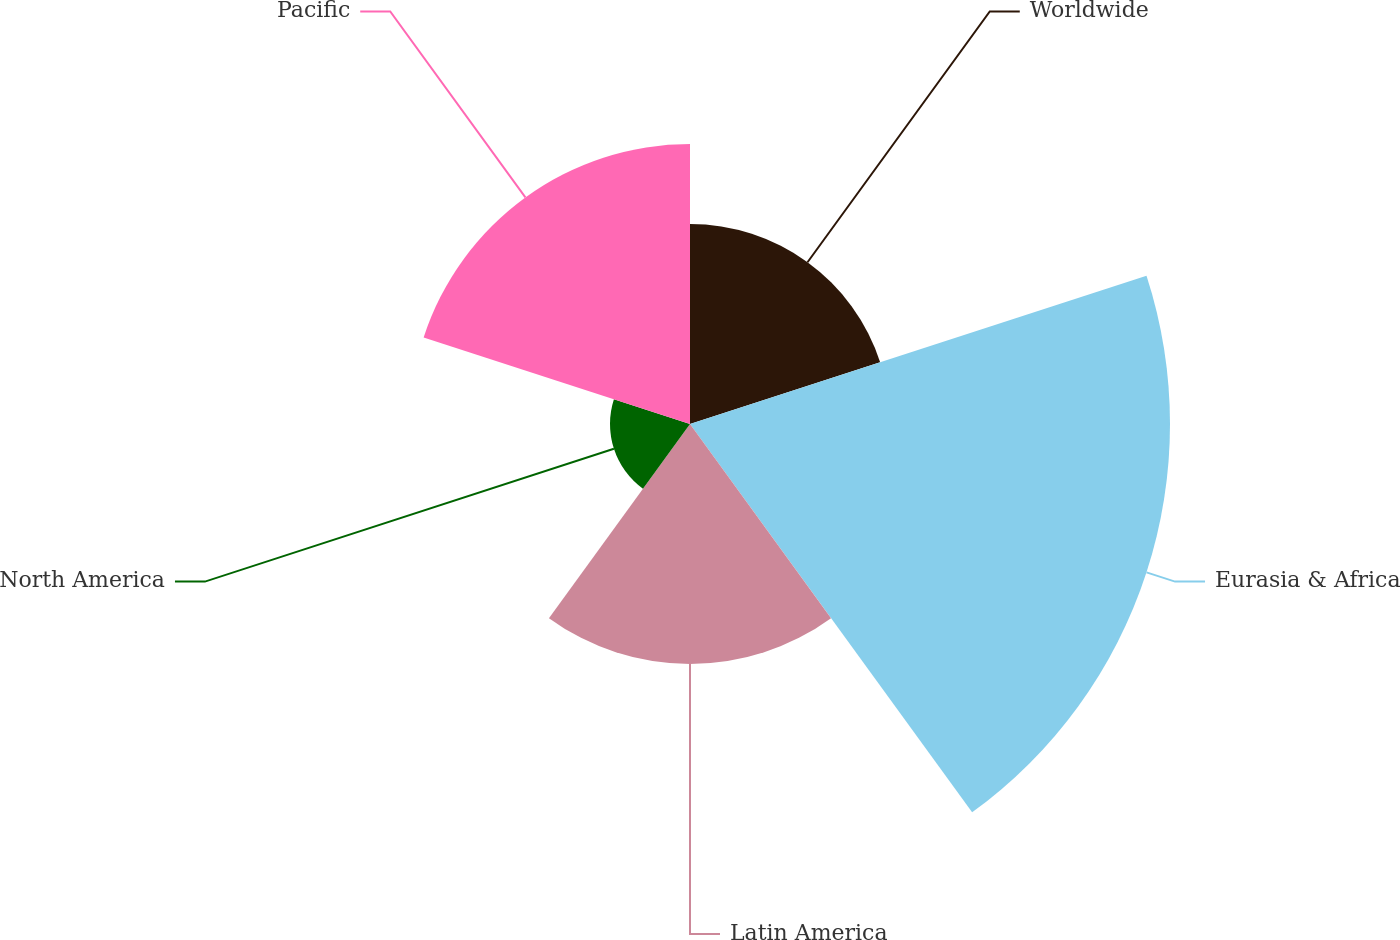Convert chart. <chart><loc_0><loc_0><loc_500><loc_500><pie_chart><fcel>Worldwide<fcel>Eurasia & Africa<fcel>Latin America<fcel>North America<fcel>Pacific<nl><fcel>15.62%<fcel>37.5%<fcel>18.75%<fcel>6.25%<fcel>21.88%<nl></chart> 